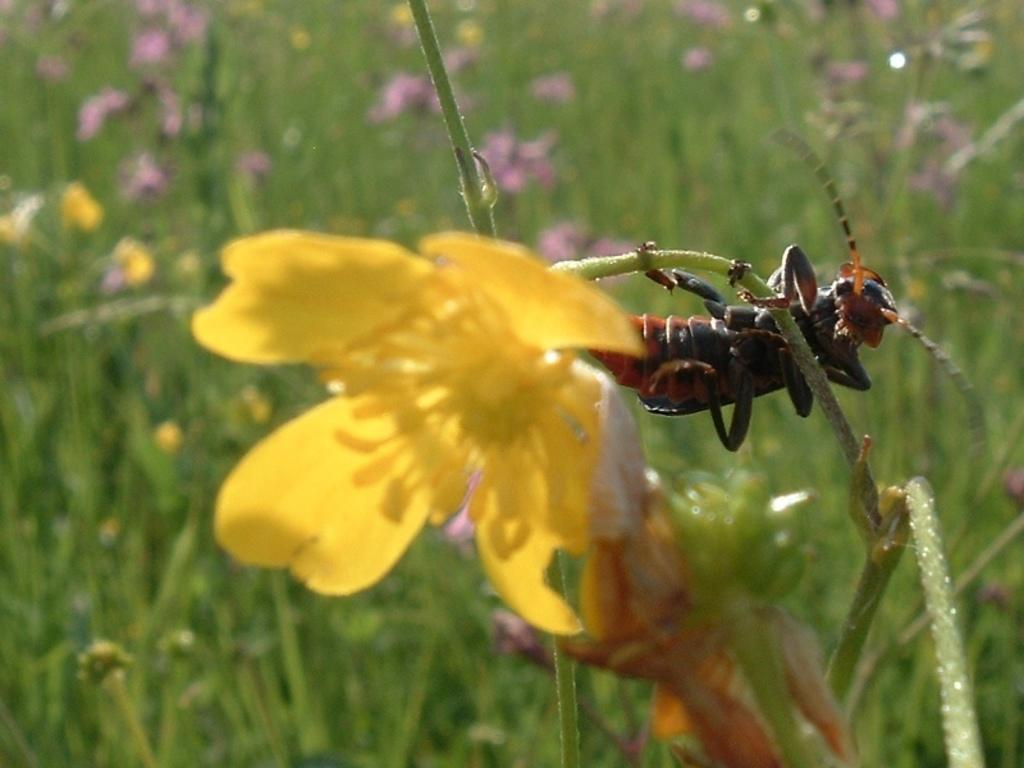What is present on the stem in the image? The insect is on a stem in the image. What is attached to the stem? The stem has a flower. What can be seen in the background of the image? The background of the image is blurry, but there is grass and flowers visible. What type of watch is the fish wearing in the image? There is no fish or watch present in the image. What year is depicted in the image? The image does not depict a specific year; it is a photograph of an insect on a stem with a flower. 